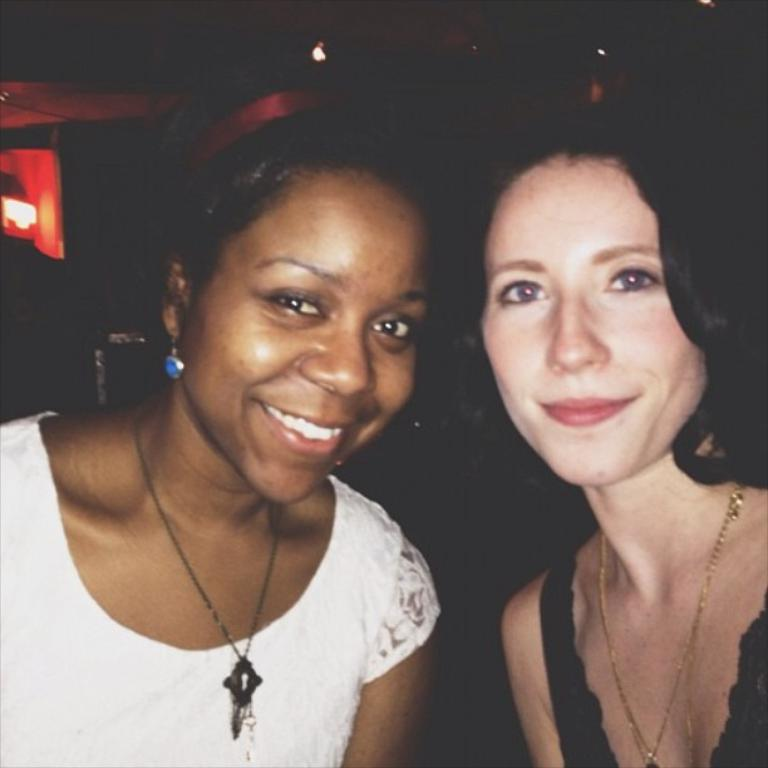How many people are in the image? There are two ladies in the image. What are the ladies doing in the image? Both ladies are smiling. What can be observed about the background of the image? The background of the image is dark. What type of print can be seen on the ladies' clothing in the image? There is no information about the ladies' clothing or any prints in the image. 